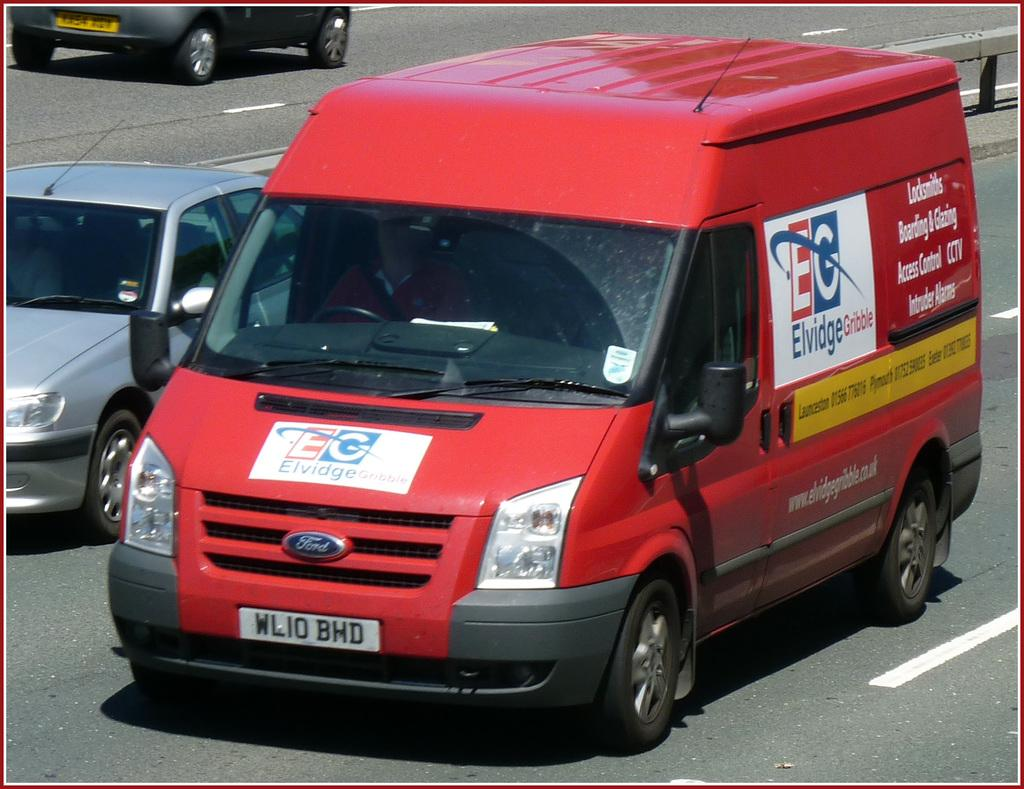Provide a one-sentence caption for the provided image. a red EG Ford van on a city street. 